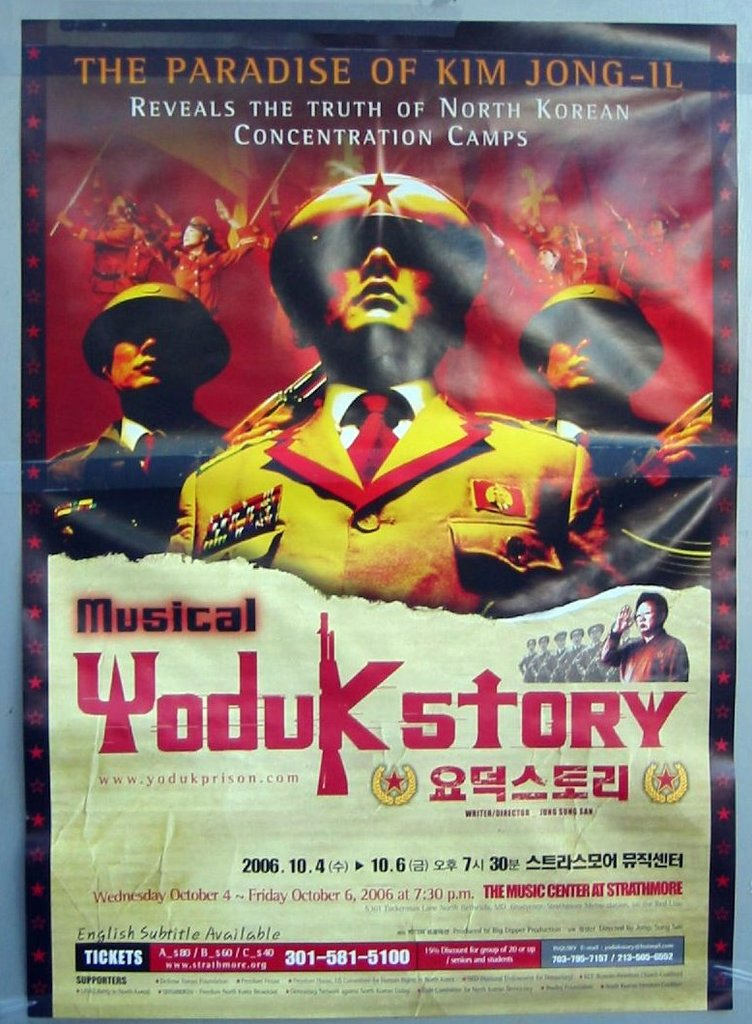What details can be found in this image about the availability and accessibility of the musical performance? The poster mentions that the musical will be held from October 4th to October 6th, 2006 at The Music Center at Strathmore. Additionally, it highlights that English subtitles are available, making the performance accessible to a non-Korean-speaking audience. Ticket purchasing information is also provided, ensuring attendees can easily plan their visit. 